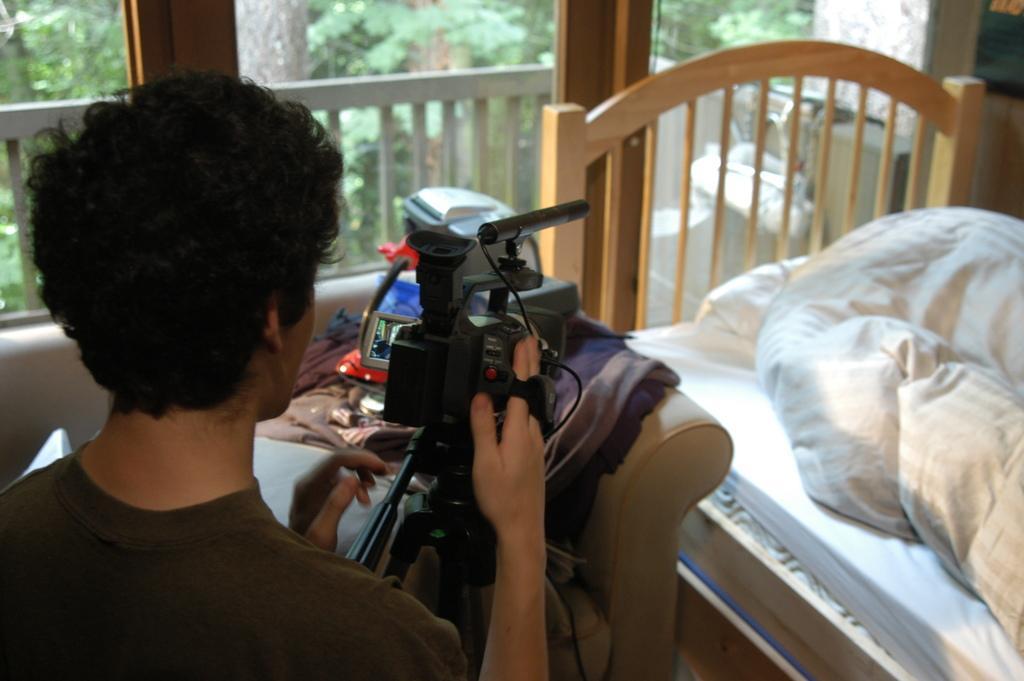Describe this image in one or two sentences. The person wearing a black shirt is recording a video with a camera in front of him and there is a bed with a white blanket on it. 